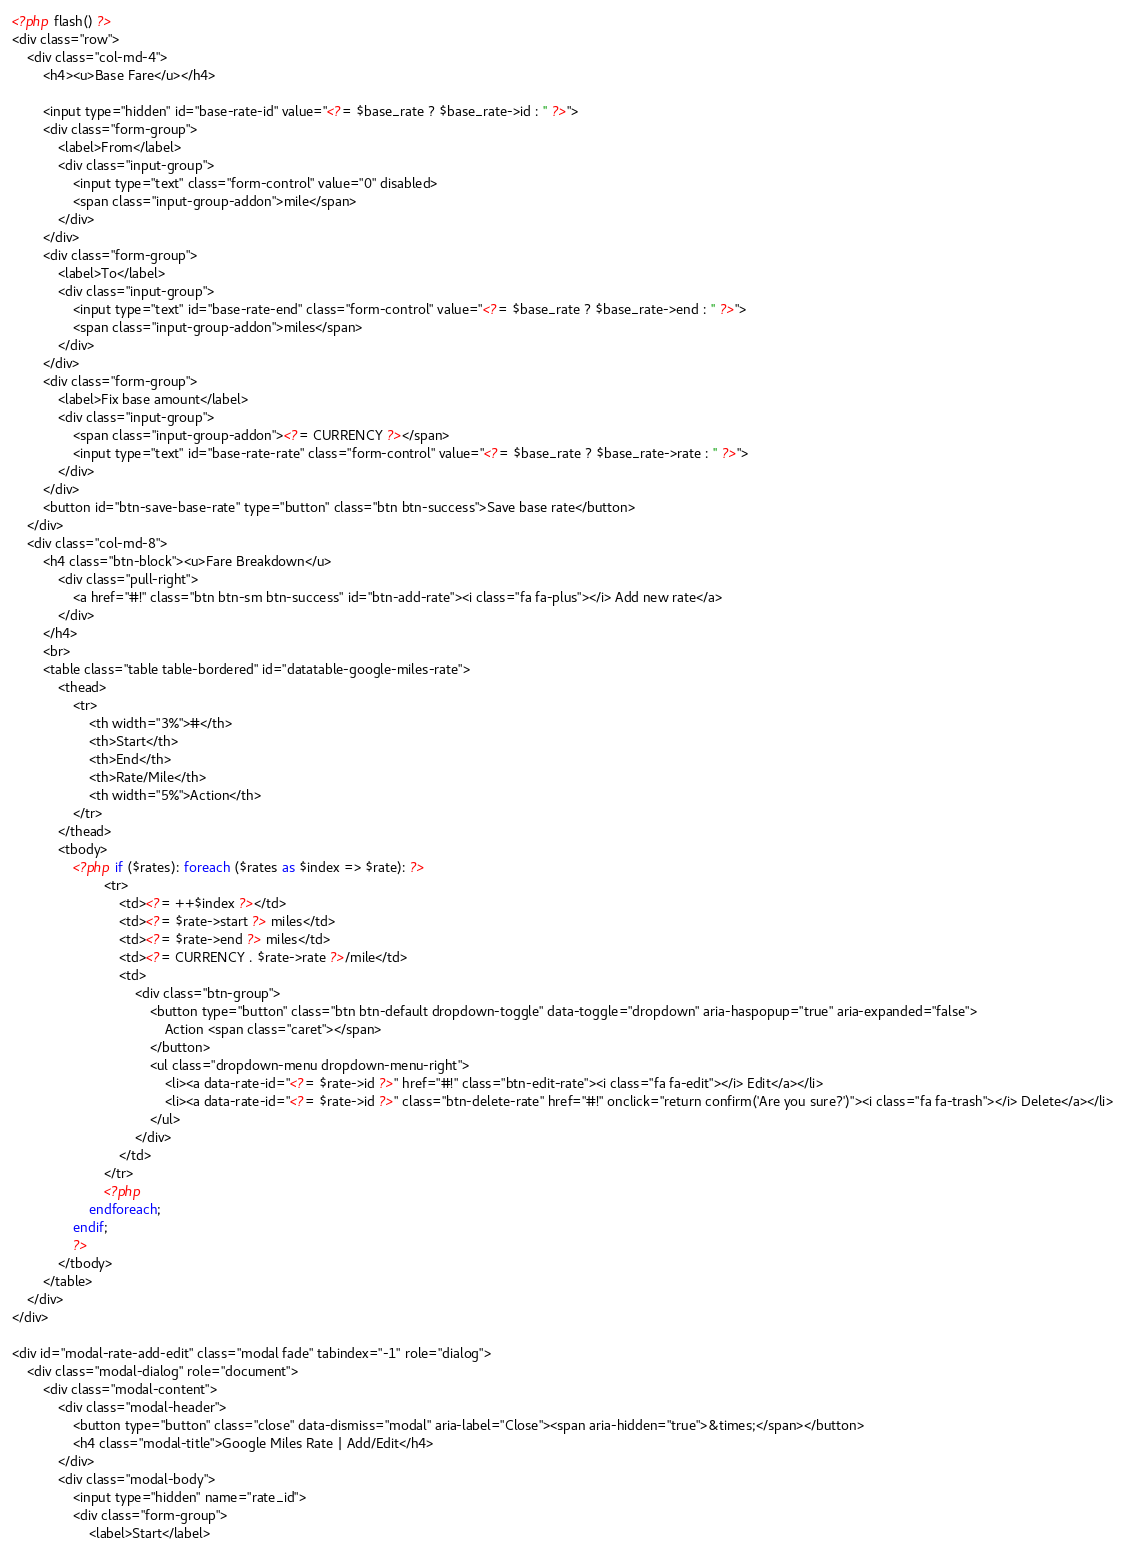Convert code to text. <code><loc_0><loc_0><loc_500><loc_500><_PHP_><?php flash() ?>
<div class="row">
    <div class="col-md-4">
        <h4><u>Base Fare</u></h4>
        
        <input type="hidden" id="base-rate-id" value="<?= $base_rate ? $base_rate->id : '' ?>">
        <div class="form-group">
            <label>From</label>
            <div class="input-group">
                <input type="text" class="form-control" value="0" disabled>
                <span class="input-group-addon">mile</span>                                        
            </div>
        </div>
        <div class="form-group">
            <label>To</label>
            <div class="input-group">
                <input type="text" id="base-rate-end" class="form-control" value="<?= $base_rate ? $base_rate->end : '' ?>">
                <span class="input-group-addon">miles</span>
            </div>
        </div>
        <div class="form-group">
            <label>Fix base amount</label>
            <div class="input-group">
                <span class="input-group-addon"><?= CURRENCY ?></span>
                <input type="text" id="base-rate-rate" class="form-control" value="<?= $base_rate ? $base_rate->rate : '' ?>">
            </div>
        </div>
        <button id="btn-save-base-rate" type="button" class="btn btn-success">Save base rate</button>
    </div>
    <div class="col-md-8">
        <h4 class="btn-block"><u>Fare Breakdown</u>
            <div class="pull-right">
                <a href="#!" class="btn btn-sm btn-success" id="btn-add-rate"><i class="fa fa-plus"></i> Add new rate</a>
            </div>
        </h4>
        <br>
        <table class="table table-bordered" id="datatable-google-miles-rate">
            <thead>
                <tr>
                    <th width="3%">#</th>
                    <th>Start</th>
                    <th>End</th>
                    <th>Rate/Mile</th>
                    <th width="5%">Action</th>
                </tr>
            </thead>
            <tbody>
                <?php if ($rates): foreach ($rates as $index => $rate): ?>
                        <tr>
                            <td><?= ++$index ?></td>
                            <td><?= $rate->start ?> miles</td>
                            <td><?= $rate->end ?> miles</td>
                            <td><?= CURRENCY . $rate->rate ?>/mile</td>
                            <td>
                                <div class="btn-group">
                                    <button type="button" class="btn btn-default dropdown-toggle" data-toggle="dropdown" aria-haspopup="true" aria-expanded="false">
                                        Action <span class="caret"></span>
                                    </button>
                                    <ul class="dropdown-menu dropdown-menu-right">
                                        <li><a data-rate-id="<?= $rate->id ?>" href="#!" class="btn-edit-rate"><i class="fa fa-edit"></i> Edit</a></li>
                                        <li><a data-rate-id="<?= $rate->id ?>" class="btn-delete-rate" href="#!" onclick="return confirm('Are you sure?')"><i class="fa fa-trash"></i> Delete</a></li>
                                    </ul>
                                </div>
                            </td>
                        </tr>
                        <?php
                    endforeach;
                endif;
                ?>
            </tbody>
        </table>
    </div>
</div>

<div id="modal-rate-add-edit" class="modal fade" tabindex="-1" role="dialog">
    <div class="modal-dialog" role="document">
        <div class="modal-content">
            <div class="modal-header">
                <button type="button" class="close" data-dismiss="modal" aria-label="Close"><span aria-hidden="true">&times;</span></button>
                <h4 class="modal-title">Google Miles Rate | Add/Edit</h4>
            </div>
            <div class="modal-body">
                <input type="hidden" name="rate_id">
                <div class="form-group">
                    <label>Start</label></code> 